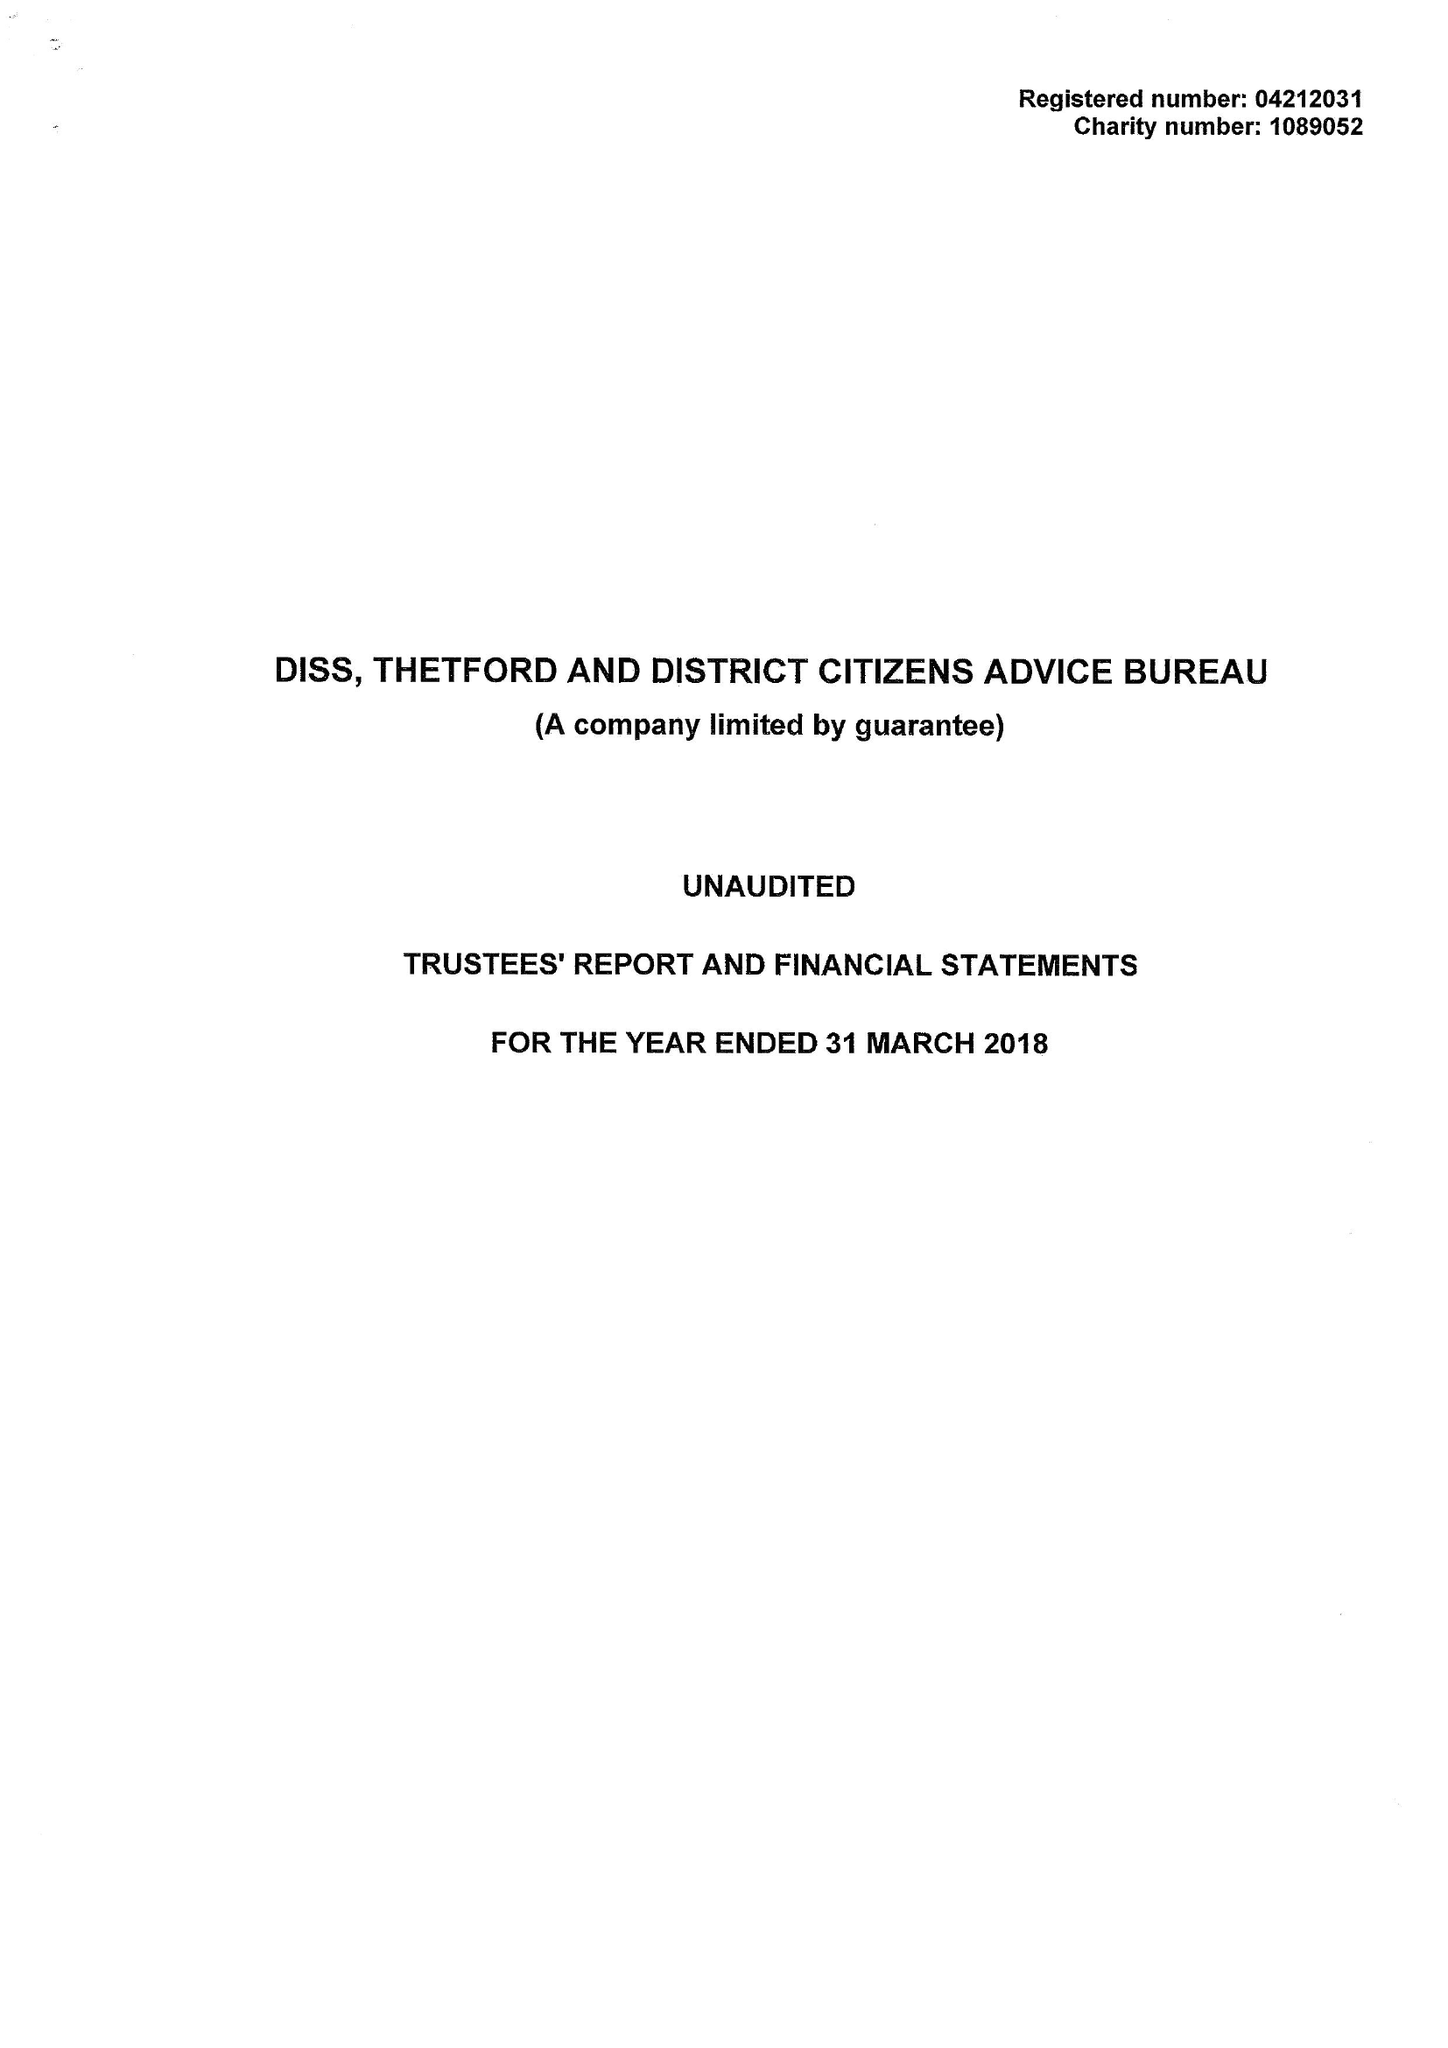What is the value for the income_annually_in_british_pounds?
Answer the question using a single word or phrase. 341782.00 